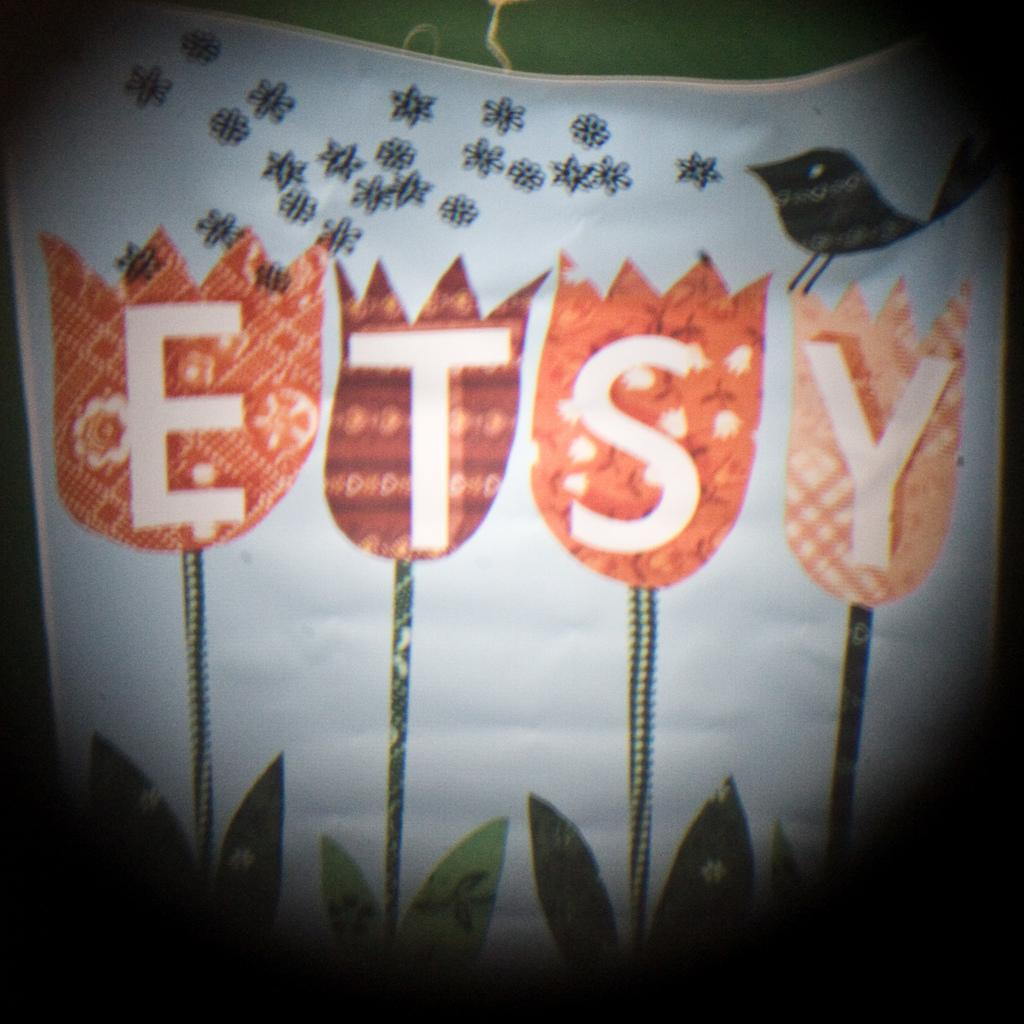What is present on the paper in the image? There is text and a drawing on the paper in the image. Where are the text and drawing located on the paper? The text and drawing are in the center of the image. What type of book is displayed on the side of the image? There is no book present in the image; it only features text and a drawing on a paper. Can you see a badge on the paper in the image? There is no badge present on the paper in the image. 